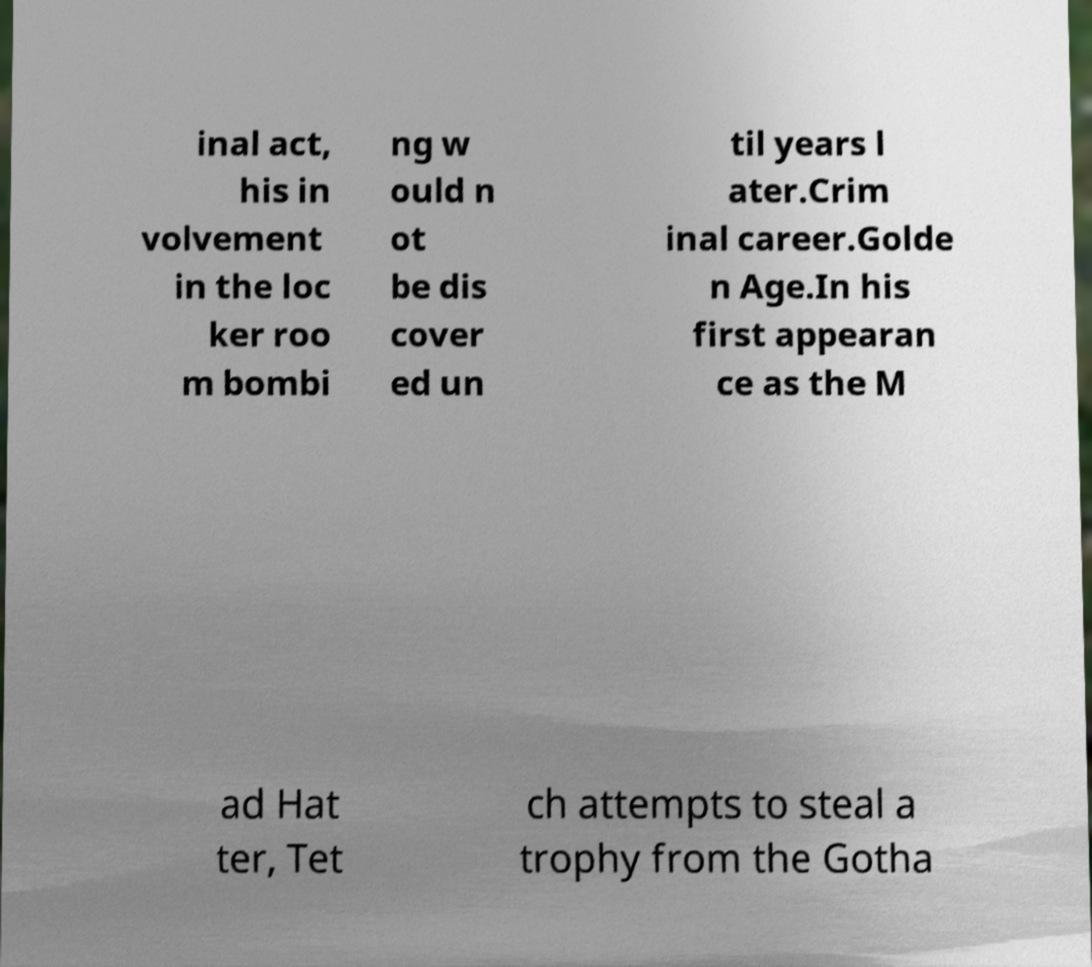Can you accurately transcribe the text from the provided image for me? inal act, his in volvement in the loc ker roo m bombi ng w ould n ot be dis cover ed un til years l ater.Crim inal career.Golde n Age.In his first appearan ce as the M ad Hat ter, Tet ch attempts to steal a trophy from the Gotha 